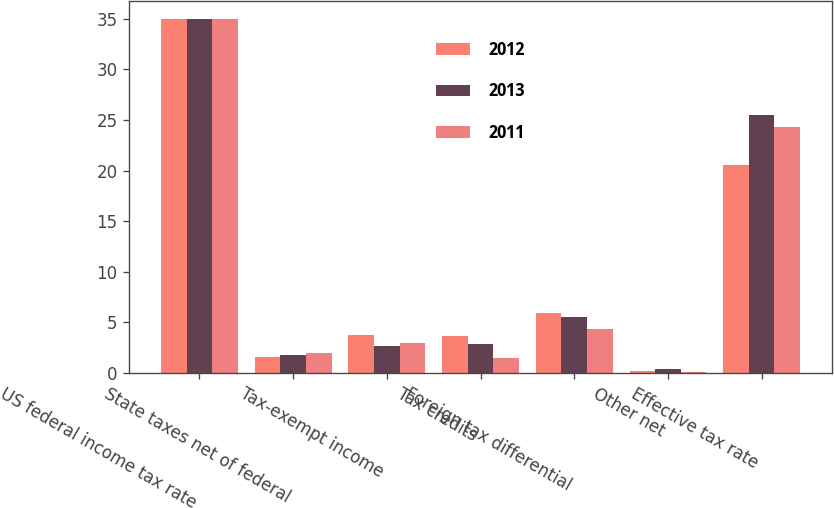Convert chart to OTSL. <chart><loc_0><loc_0><loc_500><loc_500><stacked_bar_chart><ecel><fcel>US federal income tax rate<fcel>State taxes net of federal<fcel>Tax-exempt income<fcel>Tax credits<fcel>Foreign tax differential<fcel>Other net<fcel>Effective tax rate<nl><fcel>2012<fcel>35<fcel>1.6<fcel>3.7<fcel>3.6<fcel>5.9<fcel>0.2<fcel>20.5<nl><fcel>2013<fcel>35<fcel>1.8<fcel>2.6<fcel>2.8<fcel>5.5<fcel>0.4<fcel>25.5<nl><fcel>2011<fcel>35<fcel>2<fcel>2.9<fcel>1.5<fcel>4.3<fcel>0.1<fcel>24.3<nl></chart> 